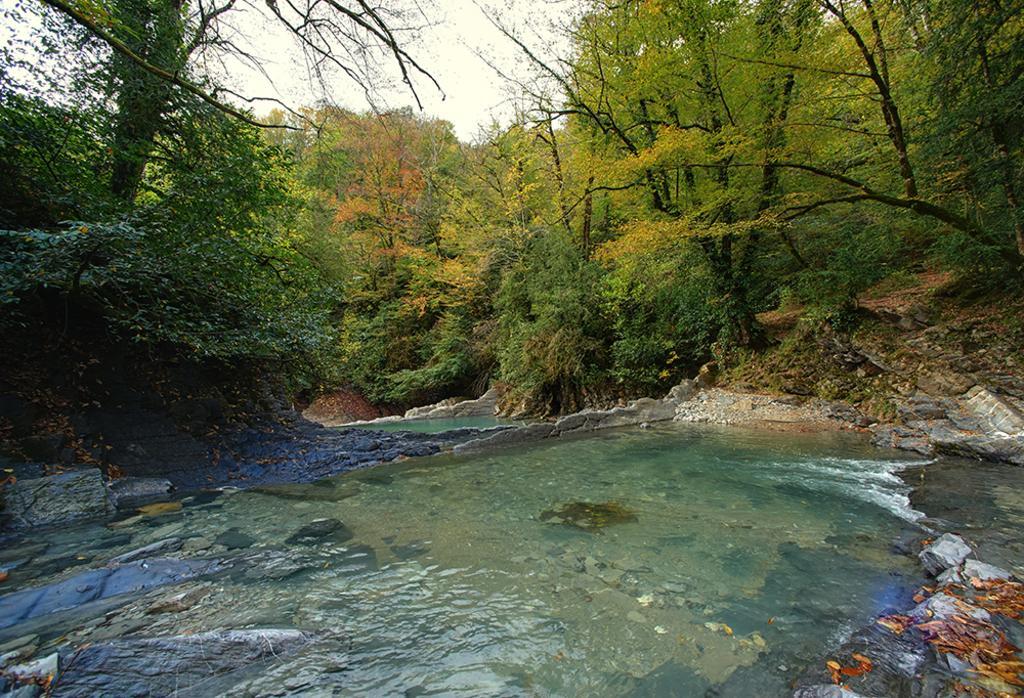In one or two sentences, can you explain what this image depicts? In the foreground of this picture, there is a river to which trees are on either side of the river. On the top, there is the sky. 